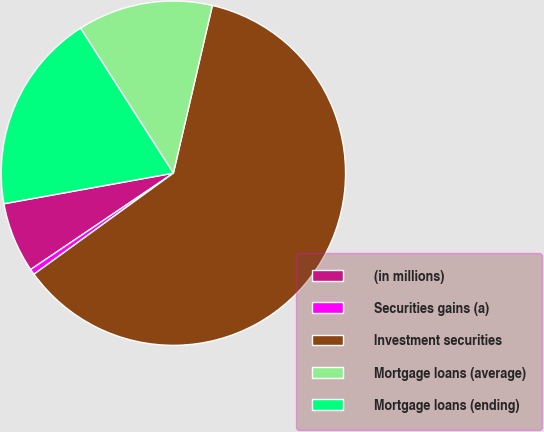<chart> <loc_0><loc_0><loc_500><loc_500><pie_chart><fcel>(in millions)<fcel>Securities gains (a)<fcel>Investment securities<fcel>Mortgage loans (average)<fcel>Mortgage loans (ending)<nl><fcel>6.61%<fcel>0.53%<fcel>61.38%<fcel>12.7%<fcel>18.78%<nl></chart> 